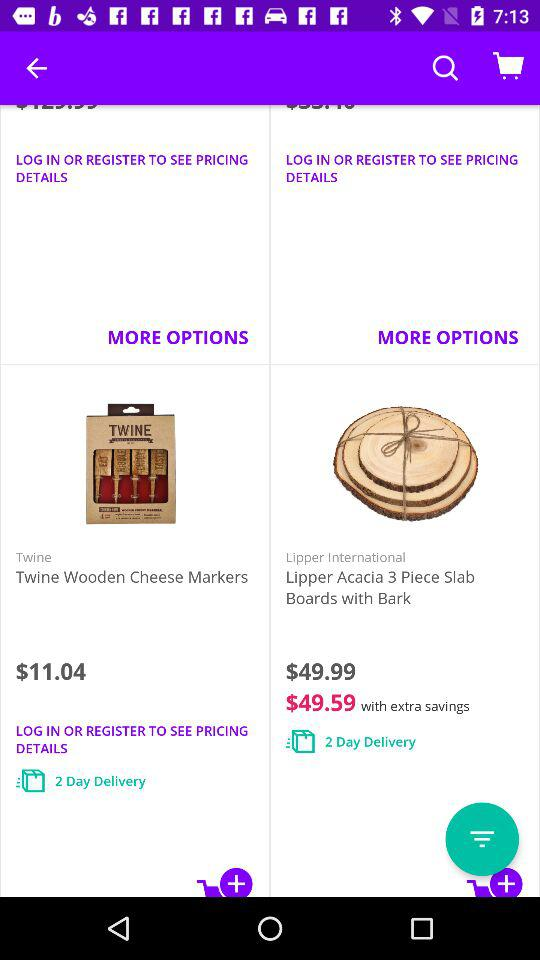What is the price of "Twine Wooden Cheese Markers"? The price of "Twine Wooden Cheese Markers" is $11.04. 